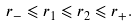Convert formula to latex. <formula><loc_0><loc_0><loc_500><loc_500>r _ { - } \leqslant r _ { 1 } \leqslant r _ { 2 } \leqslant r _ { + } .</formula> 